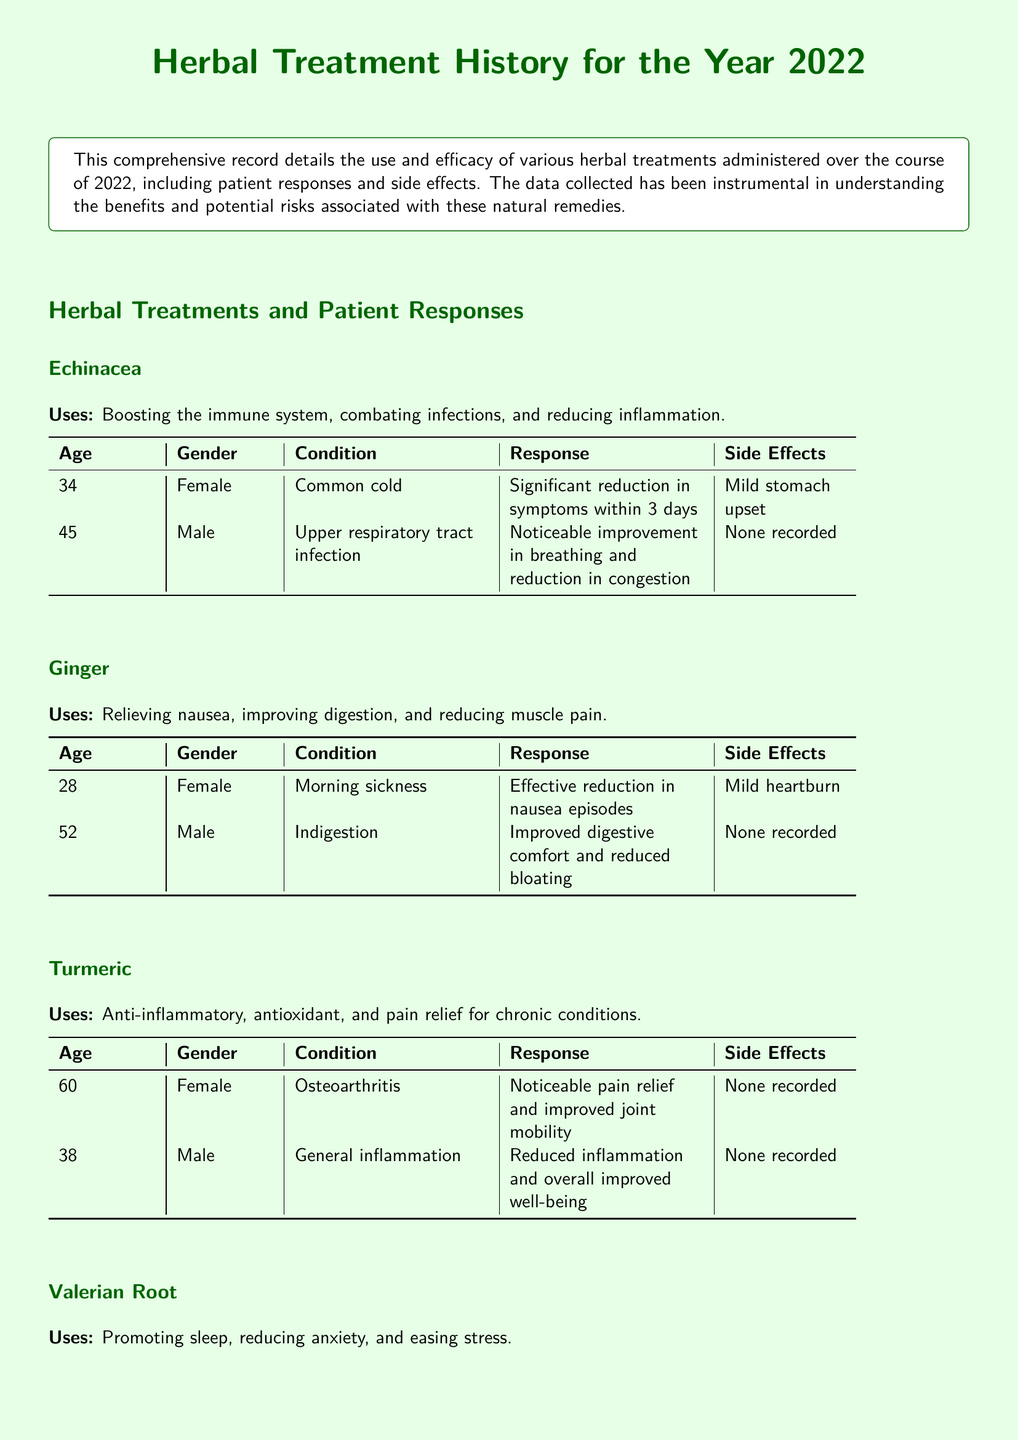What is the primary use of Echinacea? Echinacea is primarily used for boosting the immune system, combating infections, and reducing inflammation.
Answer: Boosting the immune system How many patients reported side effects when using Turmeric? The document shows a total of two patients who used Turmeric, and none of them reported side effects.
Answer: None recorded What condition was Valerian Root used to treat for a 42-year-old female? The 42-year-old female used Valerian Root to treat insomnia.
Answer: Insomnia What was the response of the 45-year-old male using Echinacea? The 45-year-old male reported noticeable improvement in breathing and reduction in congestion after using Echinacea.
Answer: Noticeable improvement in breathing and reduction in congestion Which herbal treatment was effective in reducing nausea episodes for a 28-year-old female? The 28-year-old female experienced effective reduction in nausea episodes using Ginger.
Answer: Ginger 